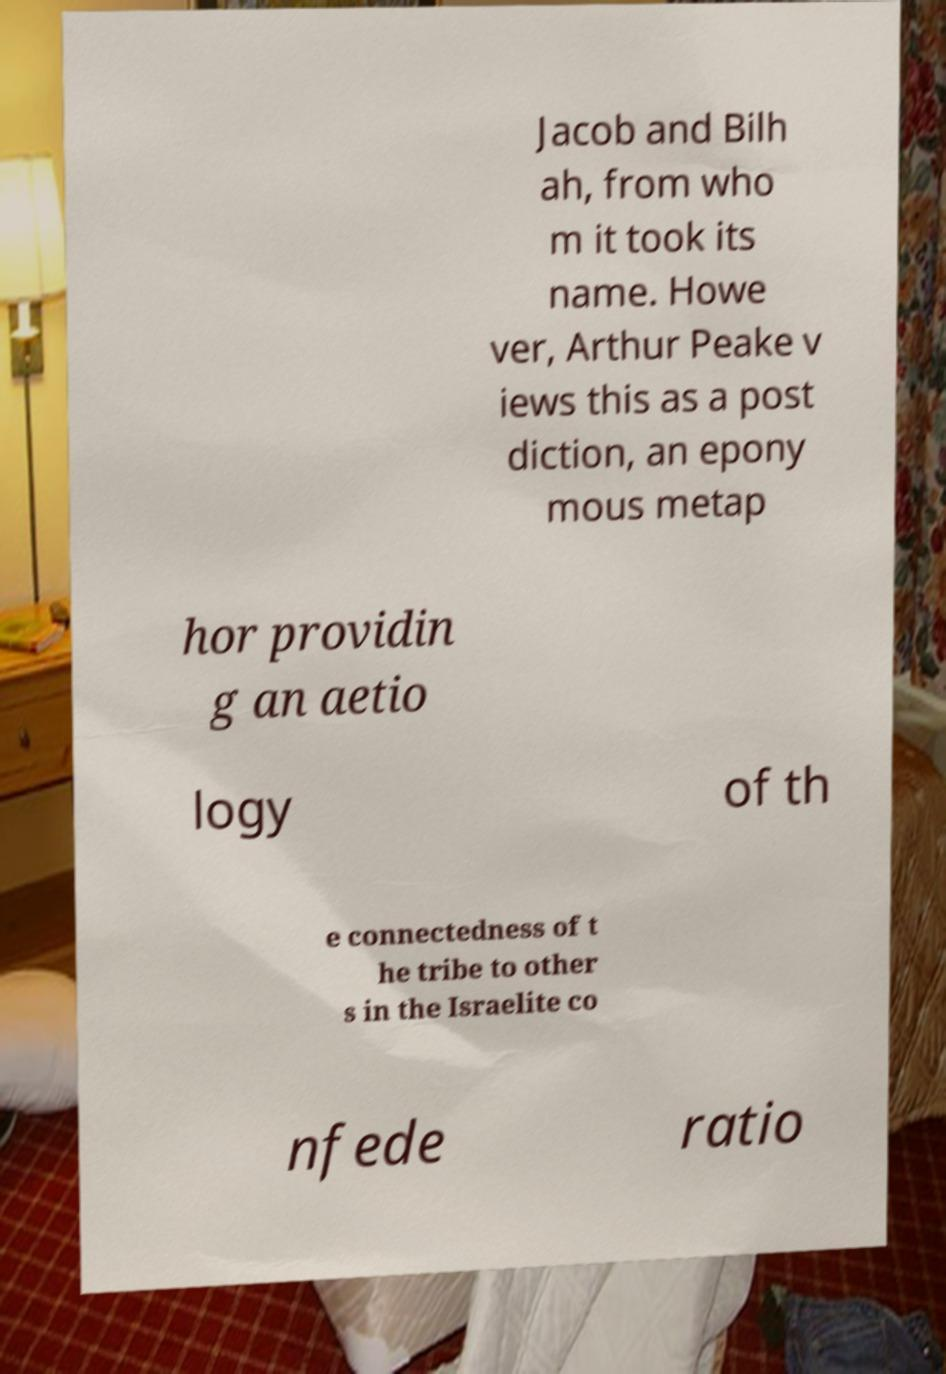Please read and relay the text visible in this image. What does it say? Jacob and Bilh ah, from who m it took its name. Howe ver, Arthur Peake v iews this as a post diction, an epony mous metap hor providin g an aetio logy of th e connectedness of t he tribe to other s in the Israelite co nfede ratio 